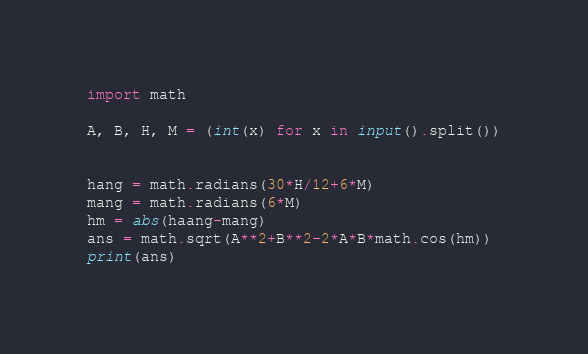Convert code to text. <code><loc_0><loc_0><loc_500><loc_500><_Python_>import math

A, B, H, M = (int(x) for x in input().split())
 

hang = math.radians(30*H/12+6*M)
mang = math.radians(6*M)
hm = abs(haang-mang)
ans = math.sqrt(A**2+B**2-2*A*B*math.cos(hm))
print(ans)</code> 